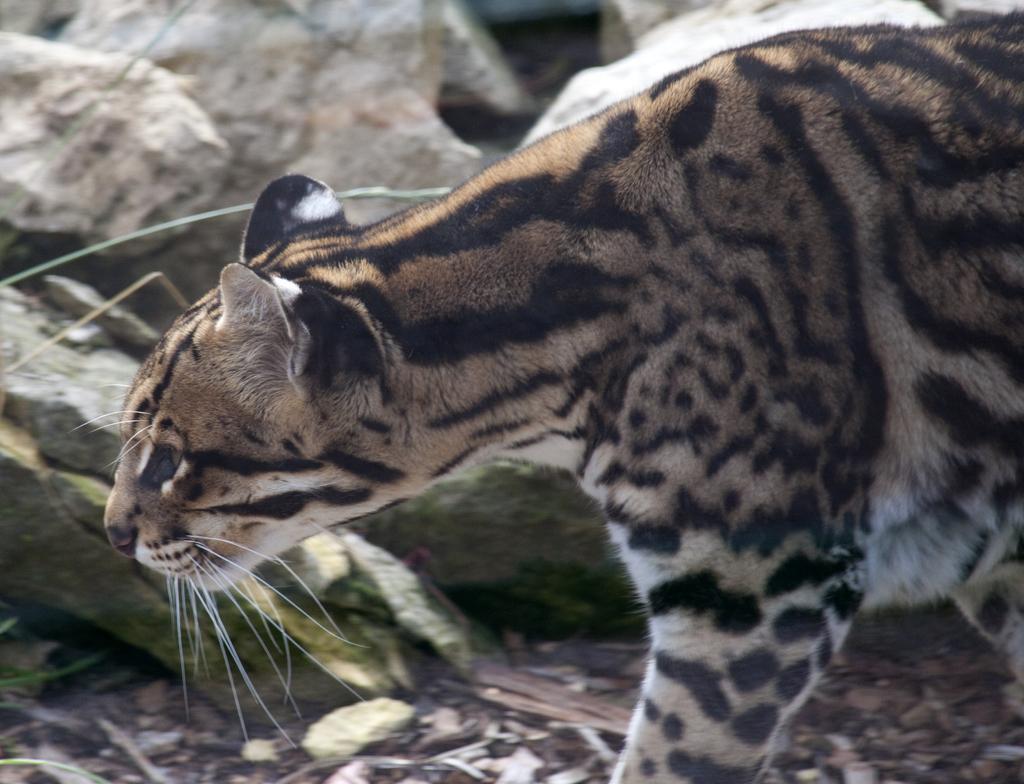Could you give a brief overview of what you see in this image? In this picture we can see an animal on the ground and in the background we can see rocks. 